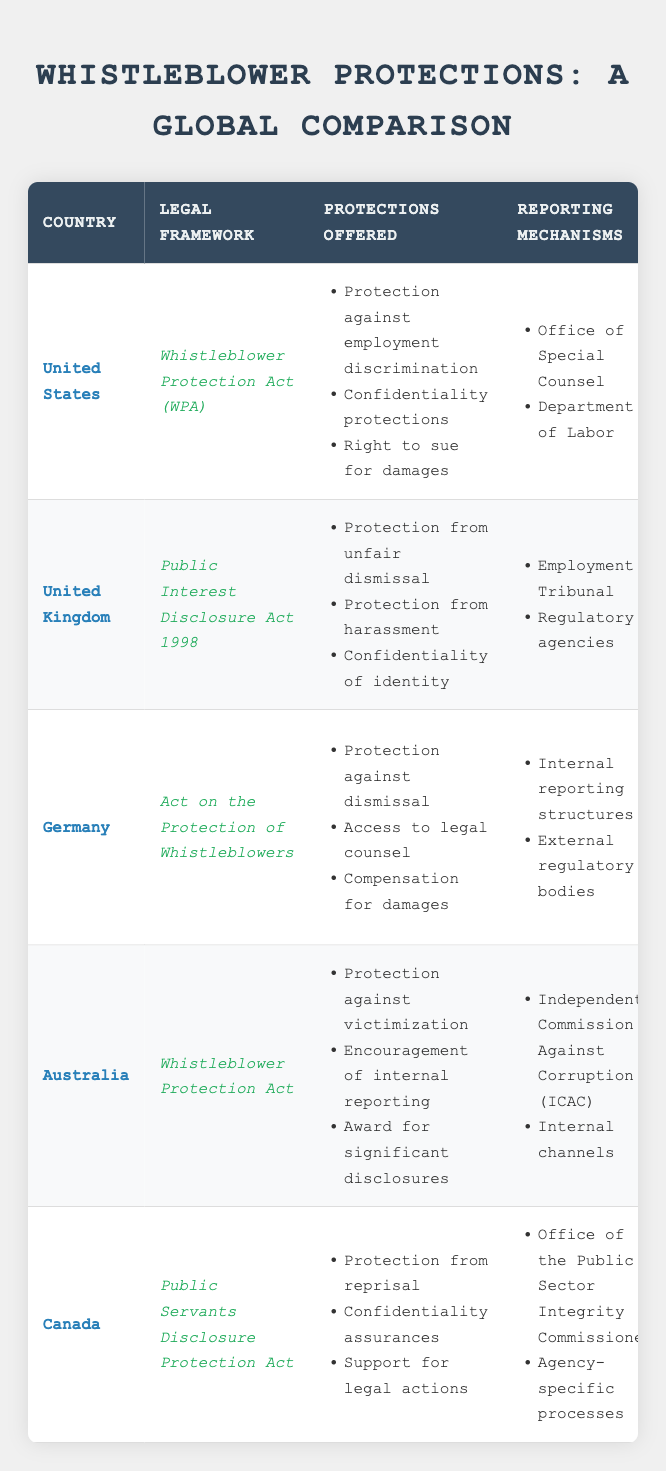What is the legal framework for whistleblower protection in Canada? The table clearly lists the legal framework for Canada as "Public Servants Disclosure Protection Act." This information can be found directly in the 'Legal Framework' column for the corresponding country row.
Answer: Public Servants Disclosure Protection Act Which country offers protection against victimization for whistleblowers? According to the 'Protections Offered' column for Australia, it specifically mentions "Protection against victimization." This is a specific protection that Australia provides to whistleblowers.
Answer: Australia Do all countries listed have confidentiality protections for whistleblowers? By checking the 'Protections Offered' column for each country, it shows that the United States, United Kingdom, Canada, and Germany all offer "Confidentiality protections" or "Confidentiality assurances." Therefore, not all countries provide this; only four do.
Answer: No In which country must disclosures be made in good faith? In the 'Limitations' column, both the United Kingdom and Canada have specific conditions that state "Must disclose in good faith." This shows that both countries emphasize the requirement of good faith for disclosures.
Answer: United Kingdom and Canada What is the total number of unique reporting mechanisms available across all countries? By counting the unique reporting mechanisms from all countries: United States has 2, United Kingdom has 2, Germany has 2, Australia has 2, and Canada has 2. Adding these gives: 2 + 2 + 2 + 2 + 2 = 10 reporting mechanisms in total. However, some mechanisms may overlap across countries; thus, a unique count might be lower.
Answer: 10 Is there a country where whistleblower disclosure protection is limited to federal employees? The 'Limitations' column indicates that the United States' whistleblower protections are "Limited to federal employees," confirming that its disclosure protection specifically targets federal personnel only.
Answer: Yes Which country has the most comprehensive total of protections offered? By reviewing the 'Protections Offered' column, we count the number of protections: United States (3), United Kingdom (3), Germany (3), Australia (3), and Canada (3). All have equivalent numbers, but comprehensive detail can vary based on specific context. Therefore, no single country stands out with more protections when just counting.
Answer: All are equal (3) How many protections offered by Germany relate to damages or compensation? The 'Protections Offered' for Germany includes "Compensation for damages," which relates directly to damages or compensation specifically. Thus, counting this gives a total of one protection relating to damages.
Answer: 1 In which country's reporting mechanism can disclosures go to an Employment Tribunal? The table shows that the United Kingdom lists "Employment Tribunal" as one of its reporting mechanisms, indicating that disclosures can indeed go to this tribunal, which is specific to the UK.
Answer: United Kingdom 